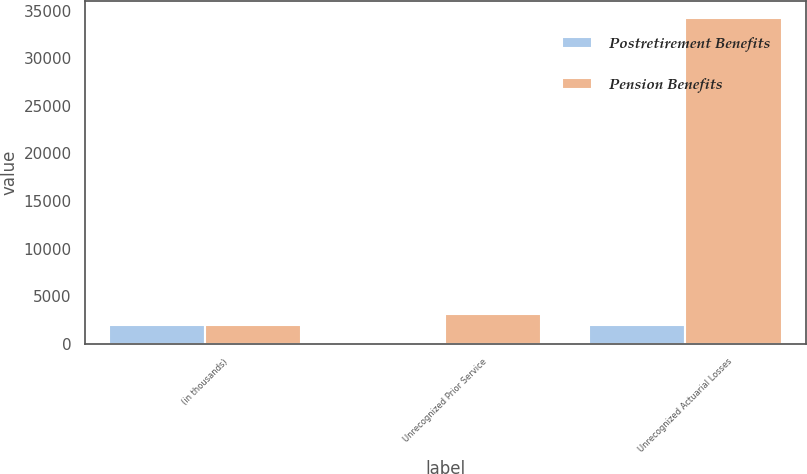<chart> <loc_0><loc_0><loc_500><loc_500><stacked_bar_chart><ecel><fcel>(in thousands)<fcel>Unrecognized Prior Service<fcel>Unrecognized Actuarial Losses<nl><fcel>Postretirement Benefits<fcel>2019<fcel>40<fcel>2019<nl><fcel>Pension Benefits<fcel>2019<fcel>3166<fcel>34266<nl></chart> 